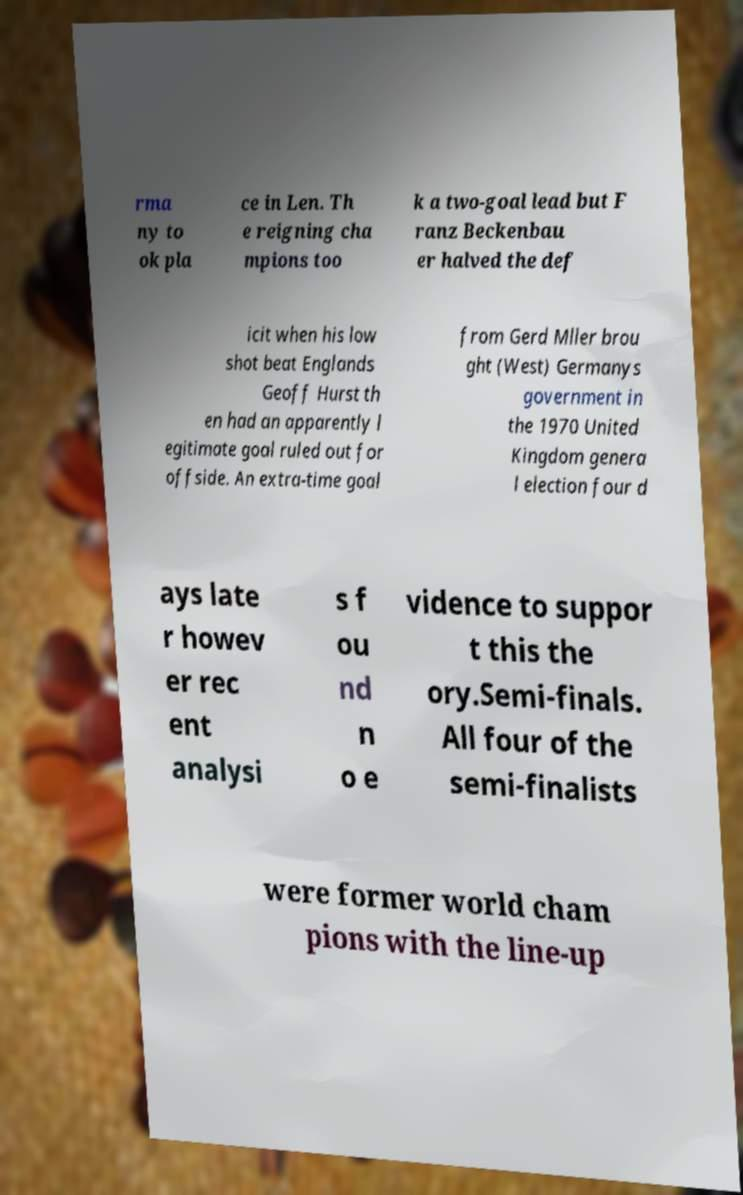Please identify and transcribe the text found in this image. rma ny to ok pla ce in Len. Th e reigning cha mpions too k a two-goal lead but F ranz Beckenbau er halved the def icit when his low shot beat Englands Geoff Hurst th en had an apparently l egitimate goal ruled out for offside. An extra-time goal from Gerd Mller brou ght (West) Germanys government in the 1970 United Kingdom genera l election four d ays late r howev er rec ent analysi s f ou nd n o e vidence to suppor t this the ory.Semi-finals. All four of the semi-finalists were former world cham pions with the line-up 